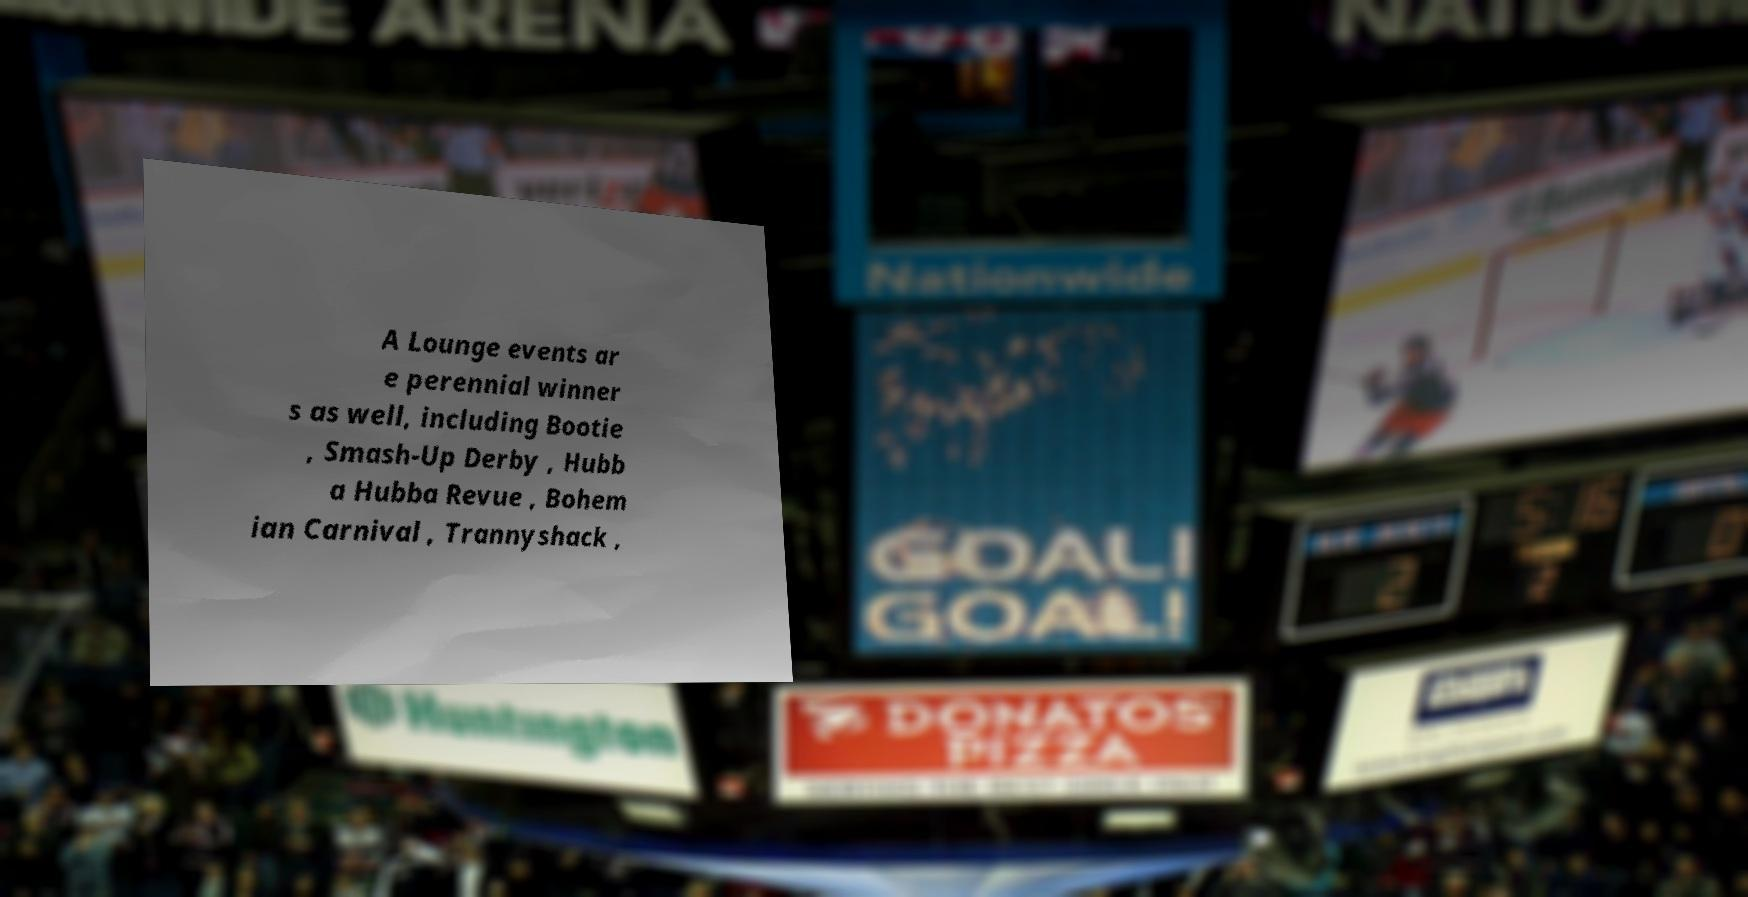Can you accurately transcribe the text from the provided image for me? A Lounge events ar e perennial winner s as well, including Bootie , Smash-Up Derby , Hubb a Hubba Revue , Bohem ian Carnival , Trannyshack , 